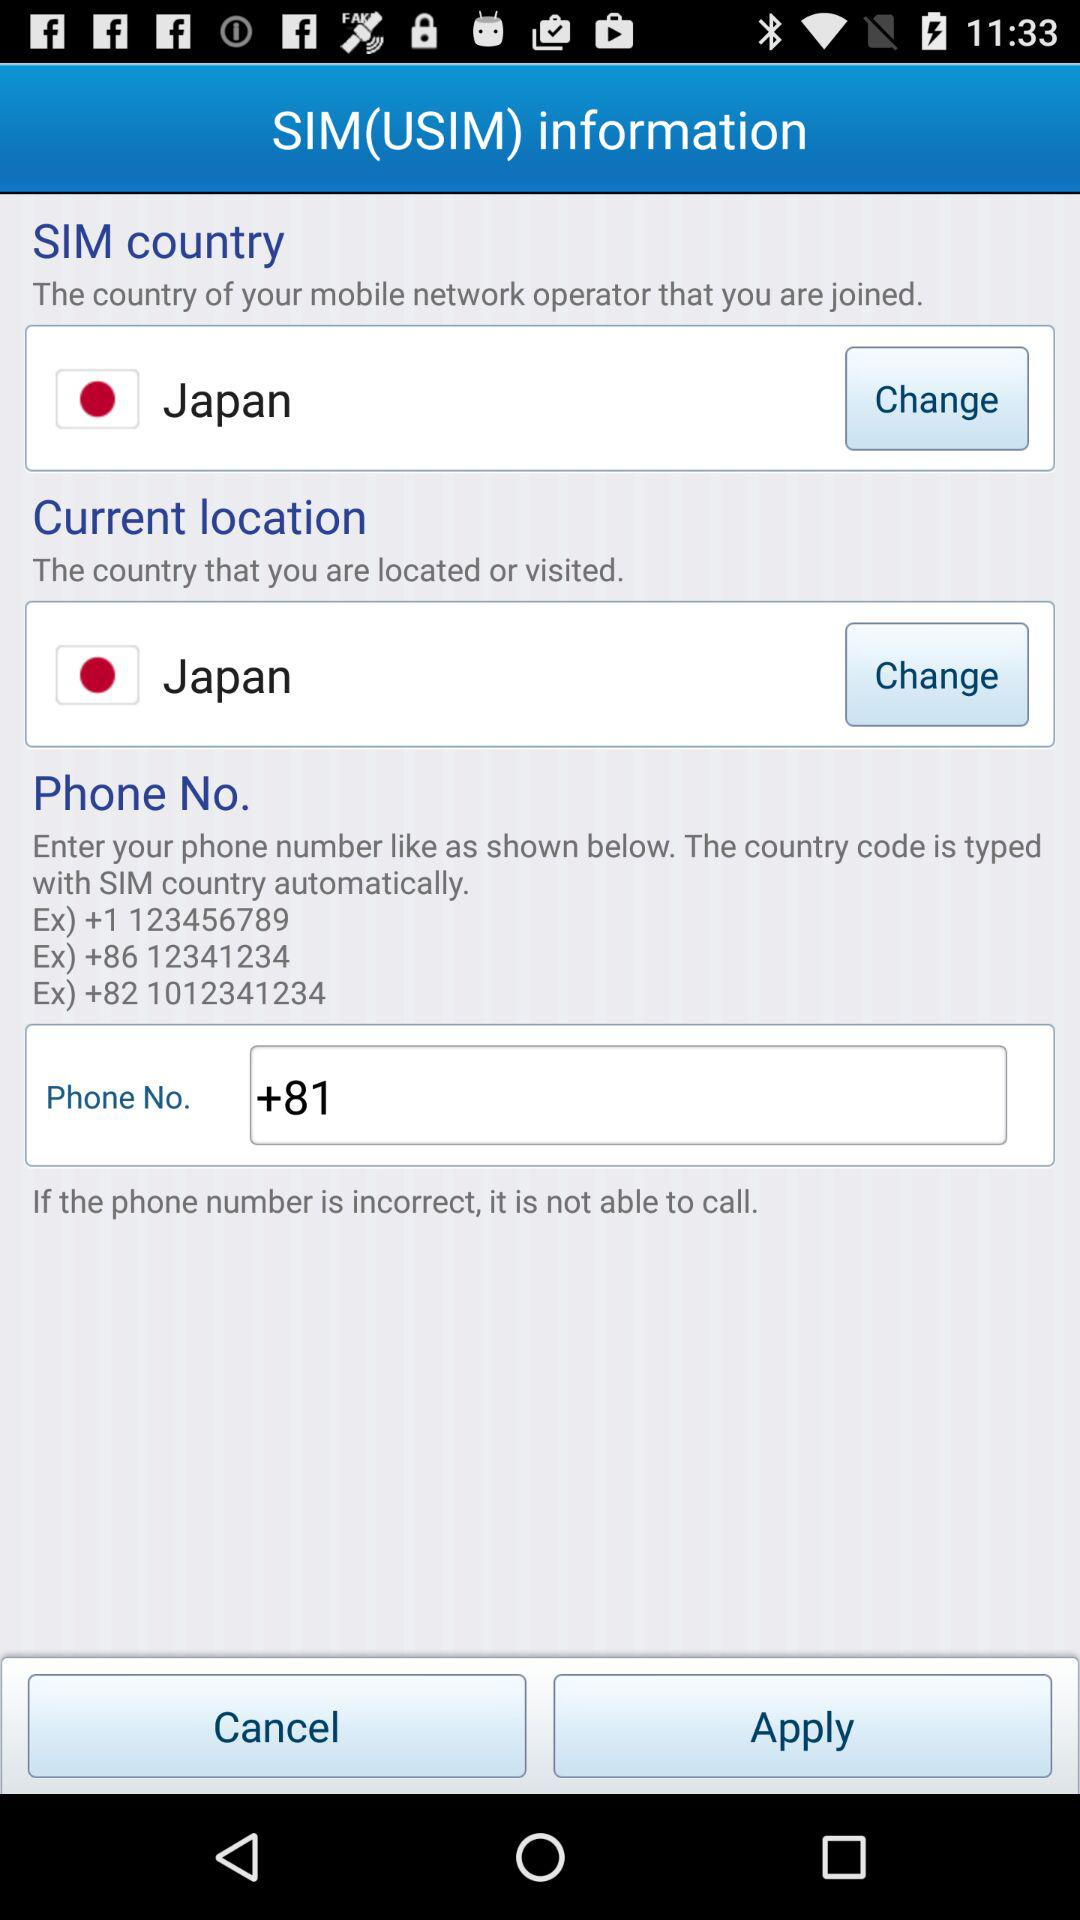What is the number that begins with the country code +82? The number is 1012341234. 